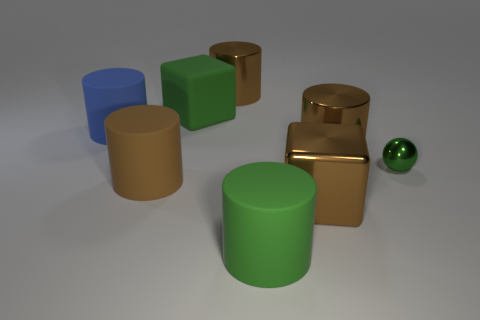Subtract all green cylinders. How many cylinders are left? 4 Subtract all blue balls. How many brown cylinders are left? 3 Subtract all blue cylinders. How many cylinders are left? 4 Subtract all gray cylinders. Subtract all cyan blocks. How many cylinders are left? 5 Add 2 big metallic cylinders. How many objects exist? 10 Subtract all cubes. How many objects are left? 6 Add 8 tiny green metallic objects. How many tiny green metallic objects are left? 9 Add 4 red objects. How many red objects exist? 4 Subtract 0 yellow balls. How many objects are left? 8 Subtract all big brown matte cylinders. Subtract all blue matte things. How many objects are left? 6 